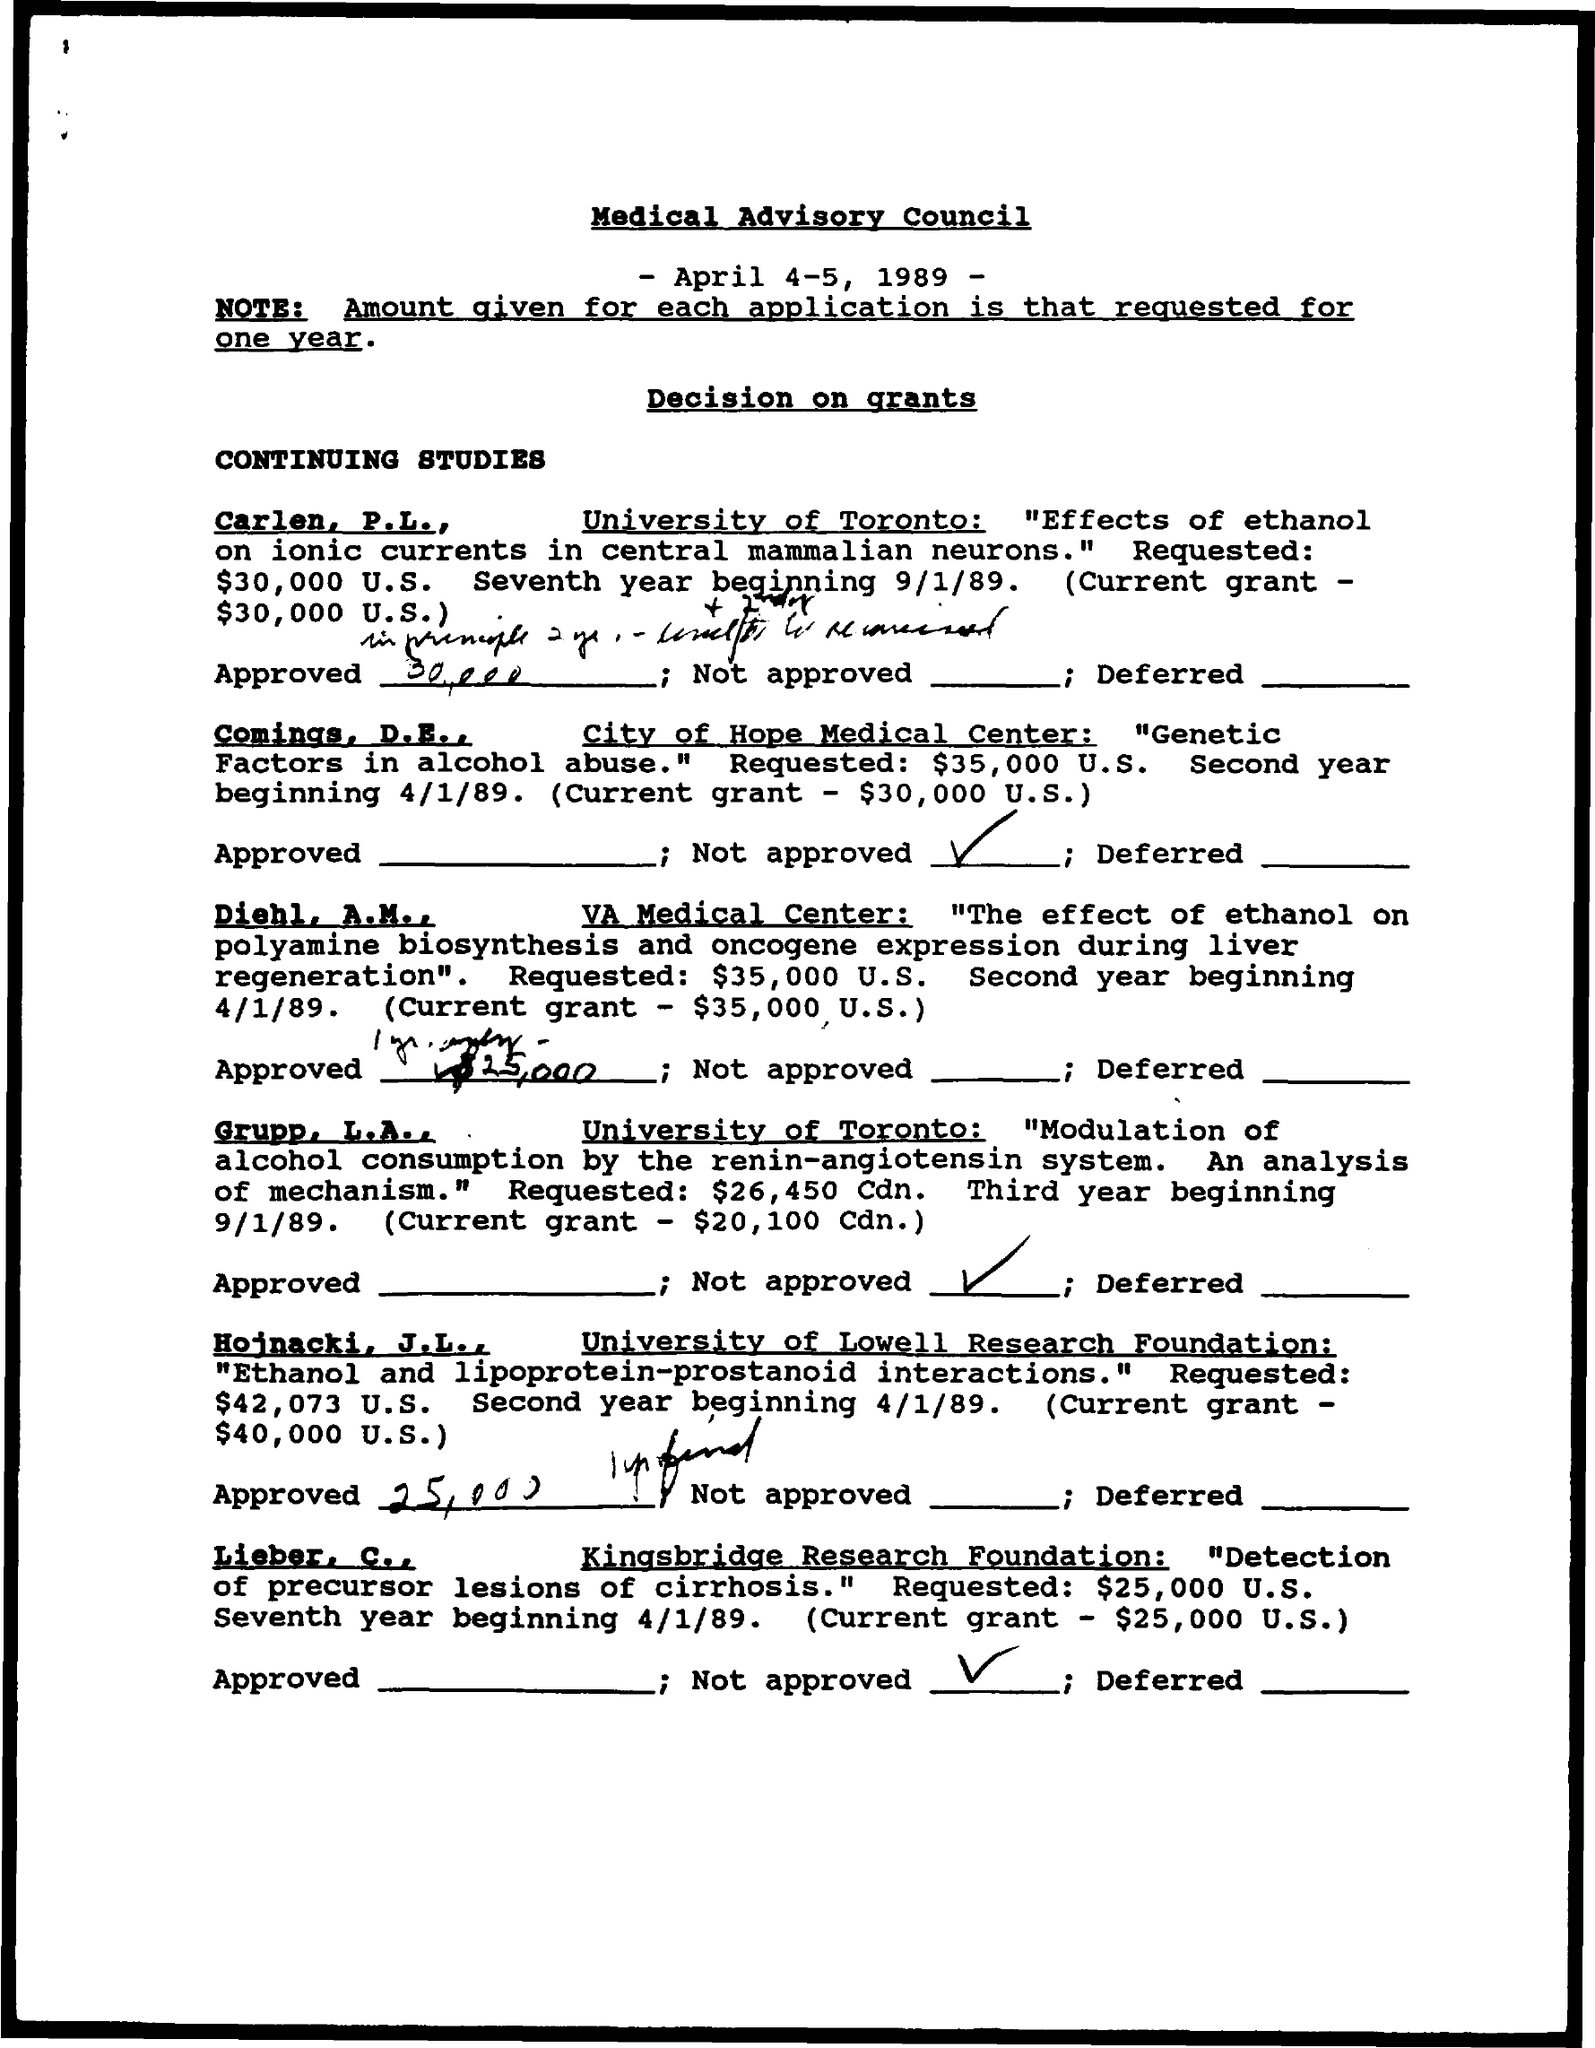What is the date on the document?
Your response must be concise. April 4-5, 1989. What is the Current Grant for Carlen, P.L.?
Your response must be concise. $30,000 U.S. What is the Current Grant for Comings, D.E.?
Ensure brevity in your answer.  $30,000 U.S. 